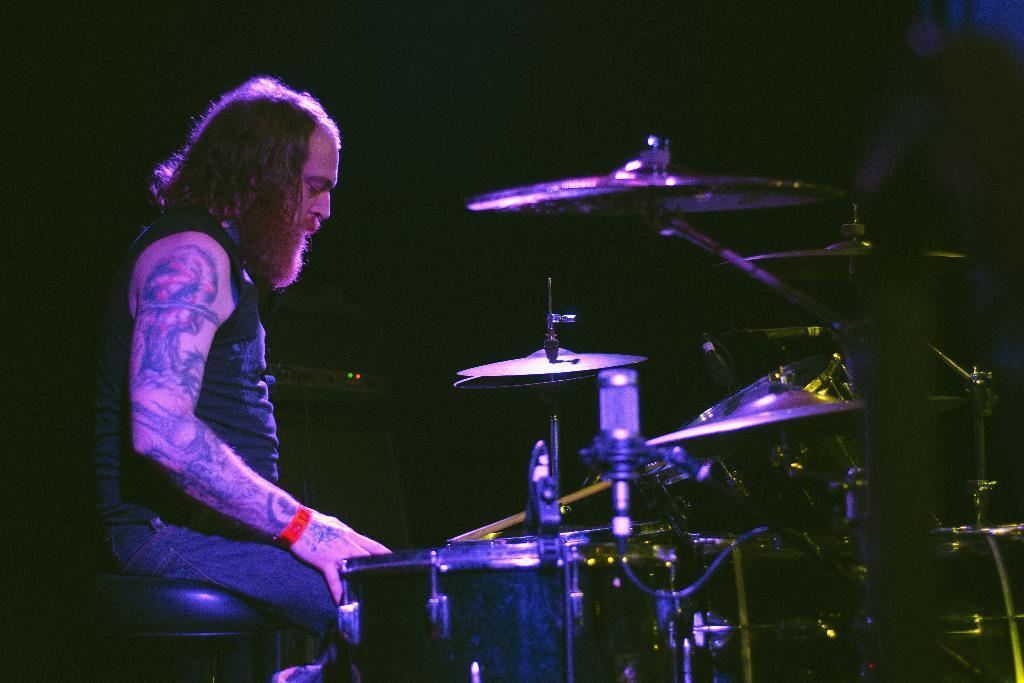Could you give a brief overview of what you see in this image? In this picture, we can see a person playing musical instrument, and we can see the dark background. 